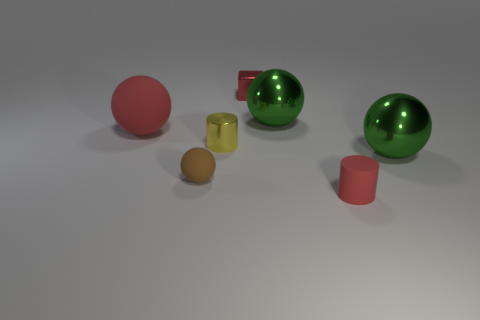What is the size of the rubber ball that is the same color as the small matte cylinder?
Your response must be concise. Large. Is the tiny metal block the same color as the big matte object?
Offer a terse response. Yes. There is a small red matte cylinder; what number of green metal objects are behind it?
Your answer should be very brief. 2. Are there the same number of yellow objects behind the tiny cube and red spheres?
Make the answer very short. No. How many objects are either small brown things or green objects?
Your answer should be compact. 3. Is there any other thing that is the same shape as the red metallic object?
Offer a terse response. No. The large metallic object that is behind the red matte object that is to the left of the brown ball is what shape?
Offer a terse response. Sphere. There is a tiny yellow thing that is the same material as the tiny cube; what is its shape?
Offer a very short reply. Cylinder. There is a brown object that is on the left side of the red object that is in front of the yellow cylinder; how big is it?
Your response must be concise. Small. There is a small red shiny object; what shape is it?
Give a very brief answer. Cube. 